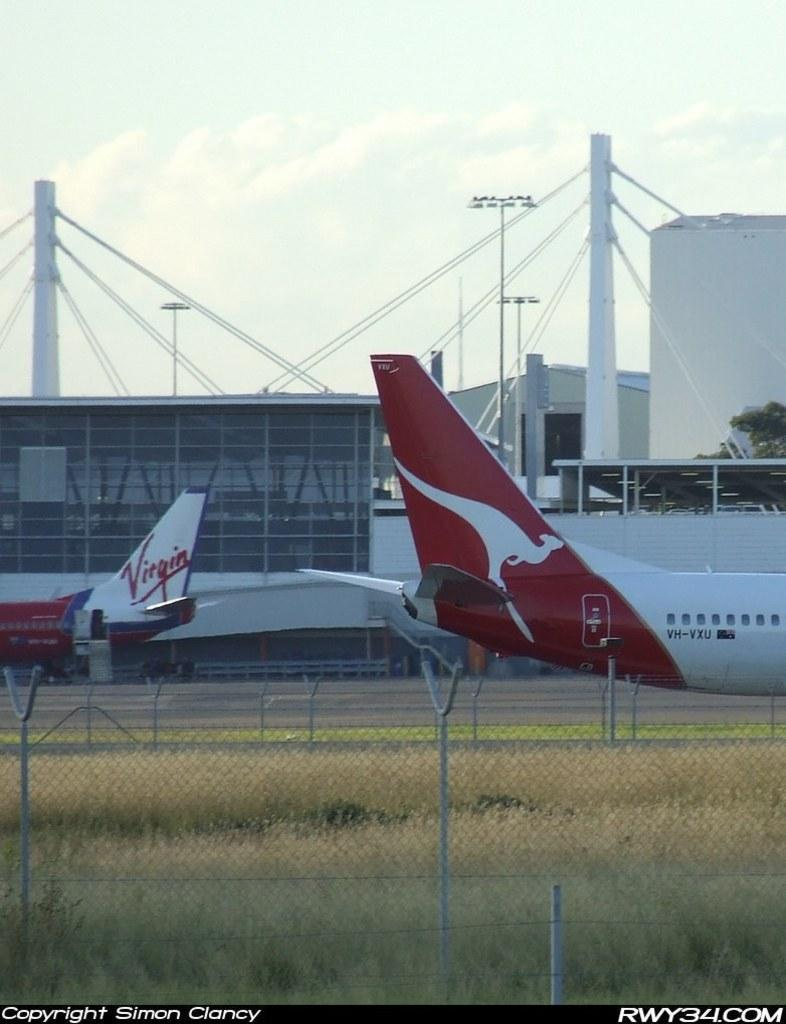Provide a one-sentence caption for the provided image. A virgin airplane is parked on a runway. 